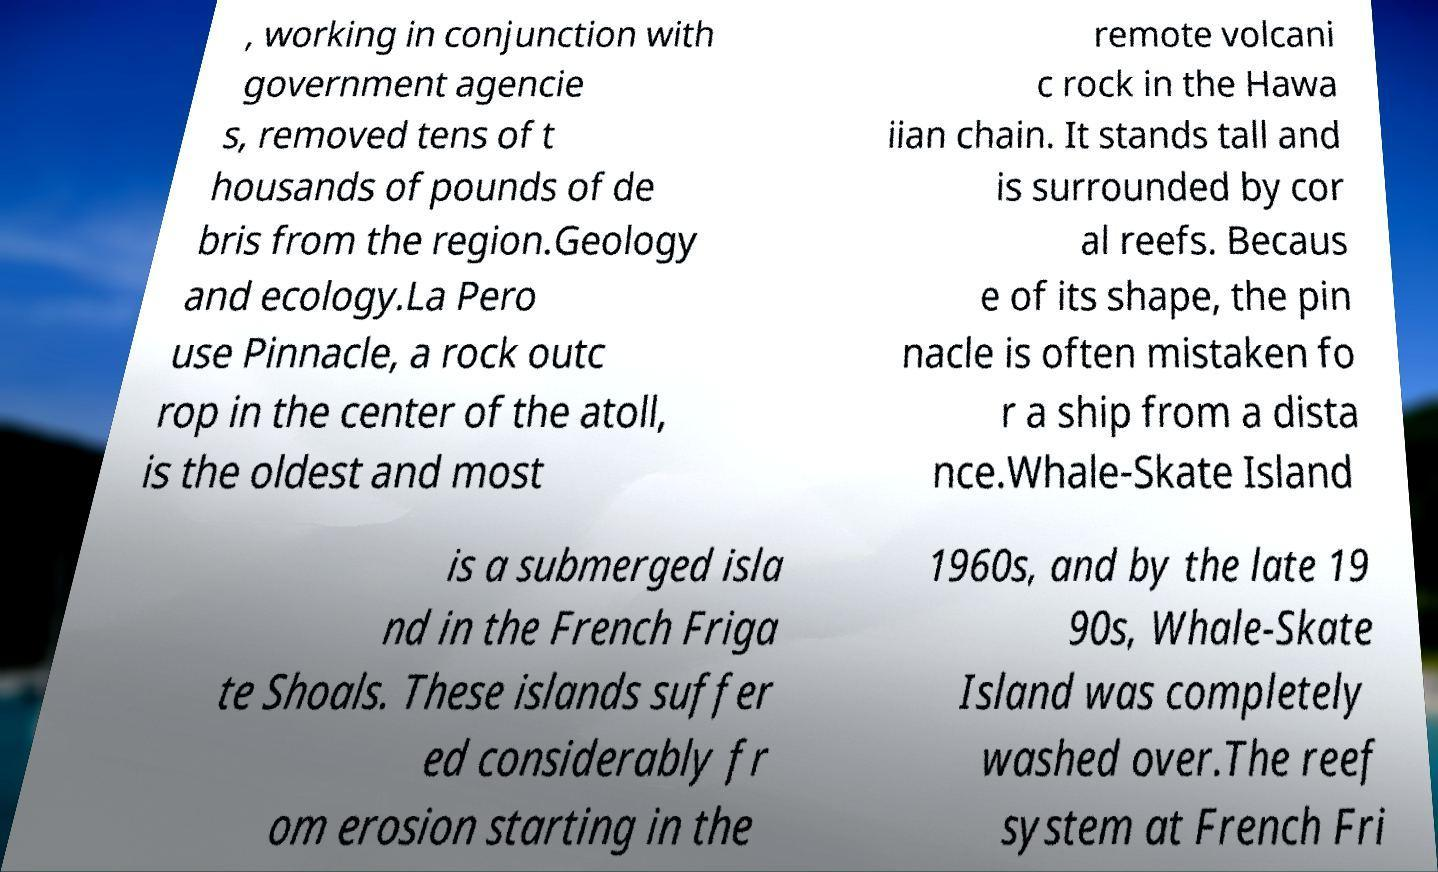Can you accurately transcribe the text from the provided image for me? , working in conjunction with government agencie s, removed tens of t housands of pounds of de bris from the region.Geology and ecology.La Pero use Pinnacle, a rock outc rop in the center of the atoll, is the oldest and most remote volcani c rock in the Hawa iian chain. It stands tall and is surrounded by cor al reefs. Becaus e of its shape, the pin nacle is often mistaken fo r a ship from a dista nce.Whale-Skate Island is a submerged isla nd in the French Friga te Shoals. These islands suffer ed considerably fr om erosion starting in the 1960s, and by the late 19 90s, Whale-Skate Island was completely washed over.The reef system at French Fri 